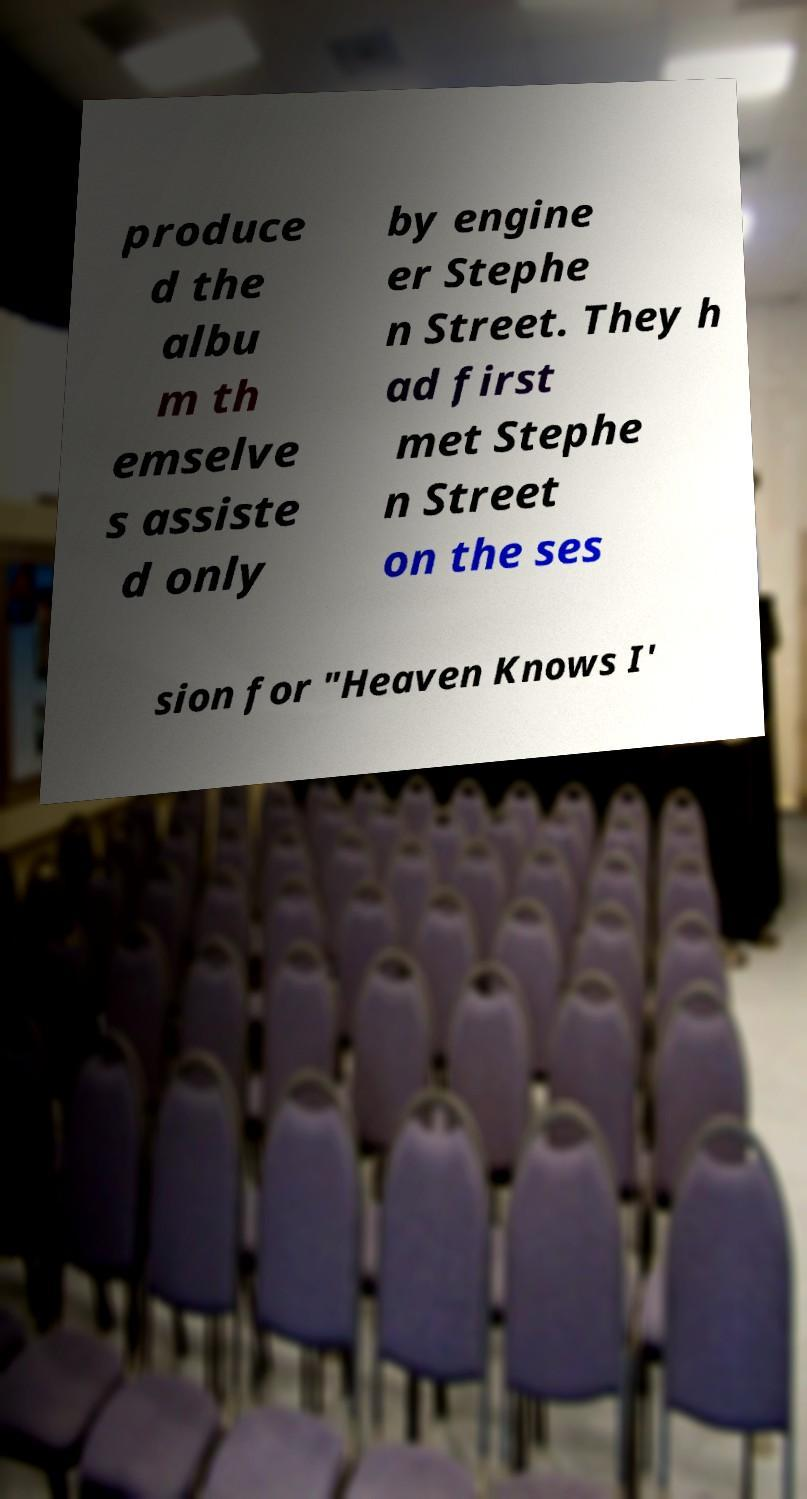For documentation purposes, I need the text within this image transcribed. Could you provide that? produce d the albu m th emselve s assiste d only by engine er Stephe n Street. They h ad first met Stephe n Street on the ses sion for "Heaven Knows I' 